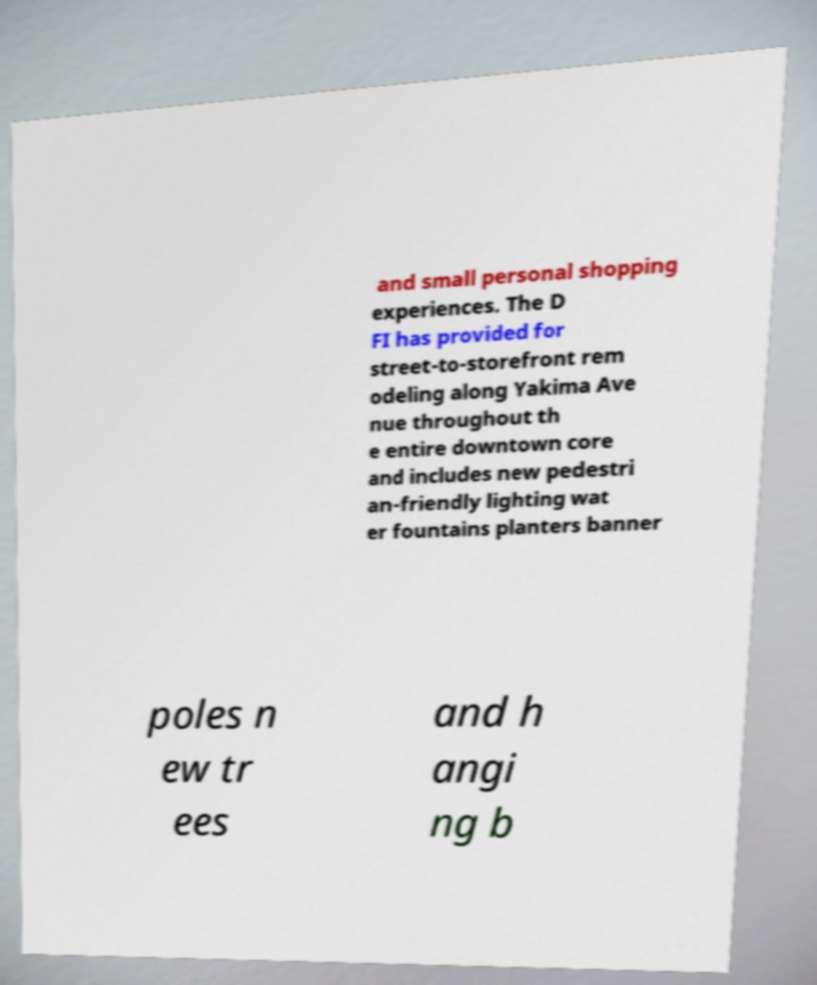Could you extract and type out the text from this image? and small personal shopping experiences. The D FI has provided for street-to-storefront rem odeling along Yakima Ave nue throughout th e entire downtown core and includes new pedestri an-friendly lighting wat er fountains planters banner poles n ew tr ees and h angi ng b 